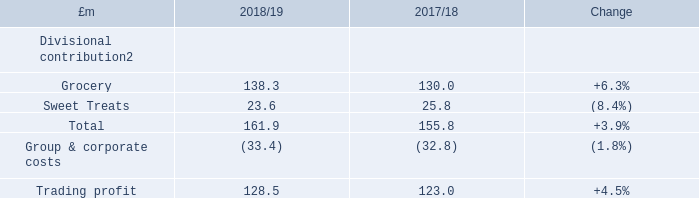Trading profit
The Group reported Trading profit of £128.5m in the year, growth of £5.5m, up +4.5% compared to 2017/18. Divisional contribution increased by £6.1m to £161.9m. The Grocery business recorded Divisional contribution growth of £8.3m to £138.3m while Sweet Treats Divisional contribution was £2.2m lower than the prior year at £23.6m. Group & corporate costs were £0.6m higher than the prior year.
In the first half of the year, Grocery Divisional contribution benefitted from previous changes in the promotional strategy of Ambrosia. The business reduced the depth of promotional deals it offered which resulted in lower volumes and revenue in the period but growth in Divisional contribution.
Additionally, Divisional contribution margins in the Grocery business grew 2.1 percentage points in the first half compared to the prior year. This is in line with margins two years ago, whereby margins in the prior year were impacted by a longer than expected process to recover input cost inflation seen across the Group’s categories.
How much was the growth in trading profit in the year 2018/19? Growth of £5.5m. What is the divisional contribution of grocery in 2018/19?
Answer scale should be: million. 138.3. What is the divisional contribution of grocery in 2017/18?
Answer scale should be: million. 130.0. What is the change in Divisional contribution of Grocery from 2018/19 to 2017/18?
Answer scale should be: million. 138.3-130.0
Answer: 8.3. What is the change in Divisional contribution of Sweet Treats from 2018/19 to 2017/18?
Answer scale should be: million. 23.6-25.8
Answer: -2.2. What is the change in Group & corporate costs from 2018/19 to 2017/18?
Answer scale should be: million. 33.4-32.8
Answer: 0.6. 